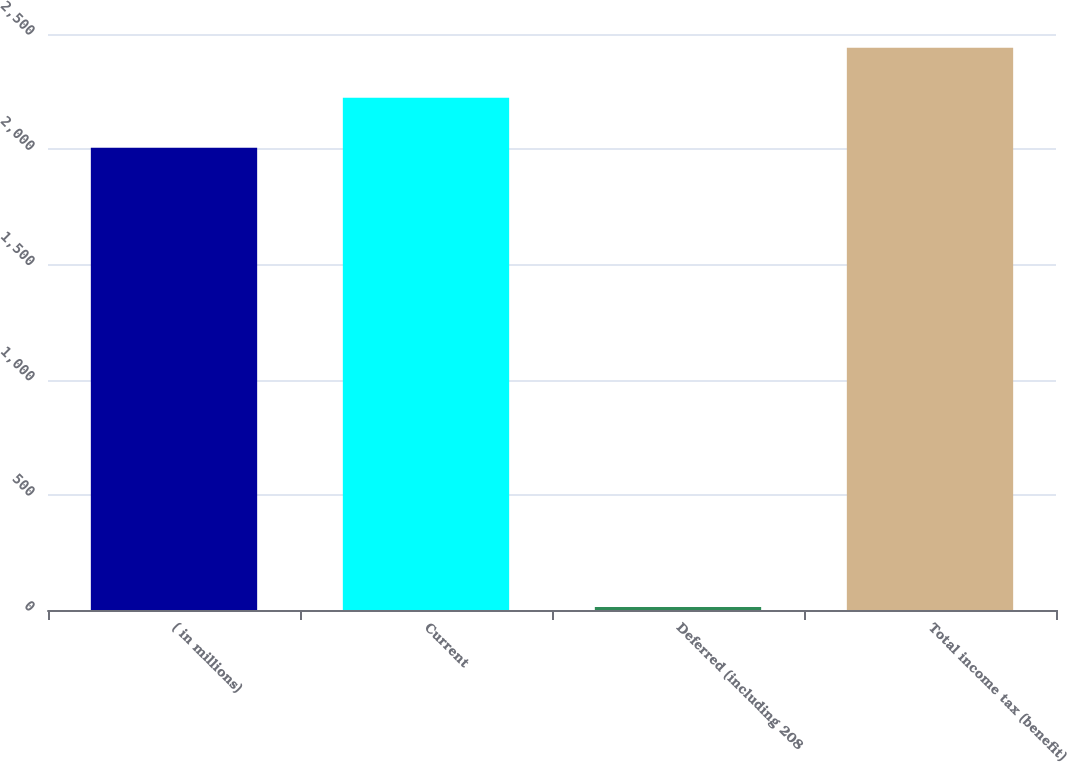Convert chart. <chart><loc_0><loc_0><loc_500><loc_500><bar_chart><fcel>( in millions)<fcel>Current<fcel>Deferred (including 208<fcel>Total income tax (benefit)<nl><fcel>2006<fcel>2223.2<fcel>13<fcel>2440.4<nl></chart> 